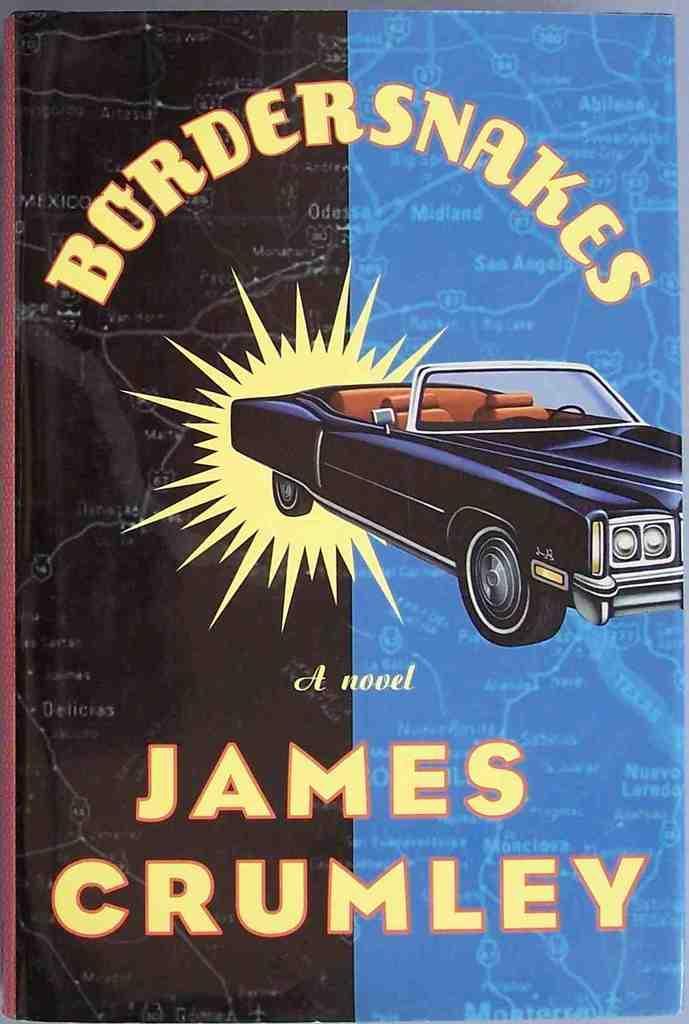Please provide a concise description of this image. In this picture we can see a poster. On this poster we can see a car. 